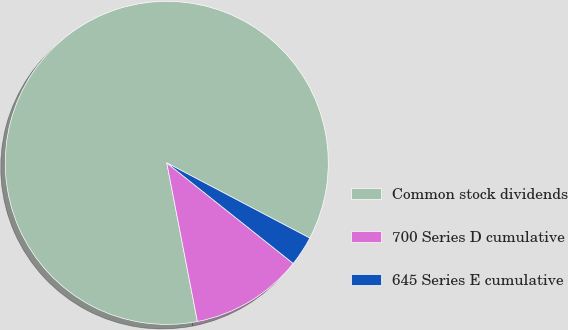Convert chart. <chart><loc_0><loc_0><loc_500><loc_500><pie_chart><fcel>Common stock dividends<fcel>700 Series D cumulative<fcel>645 Series E cumulative<nl><fcel>85.74%<fcel>11.27%<fcel>2.99%<nl></chart> 